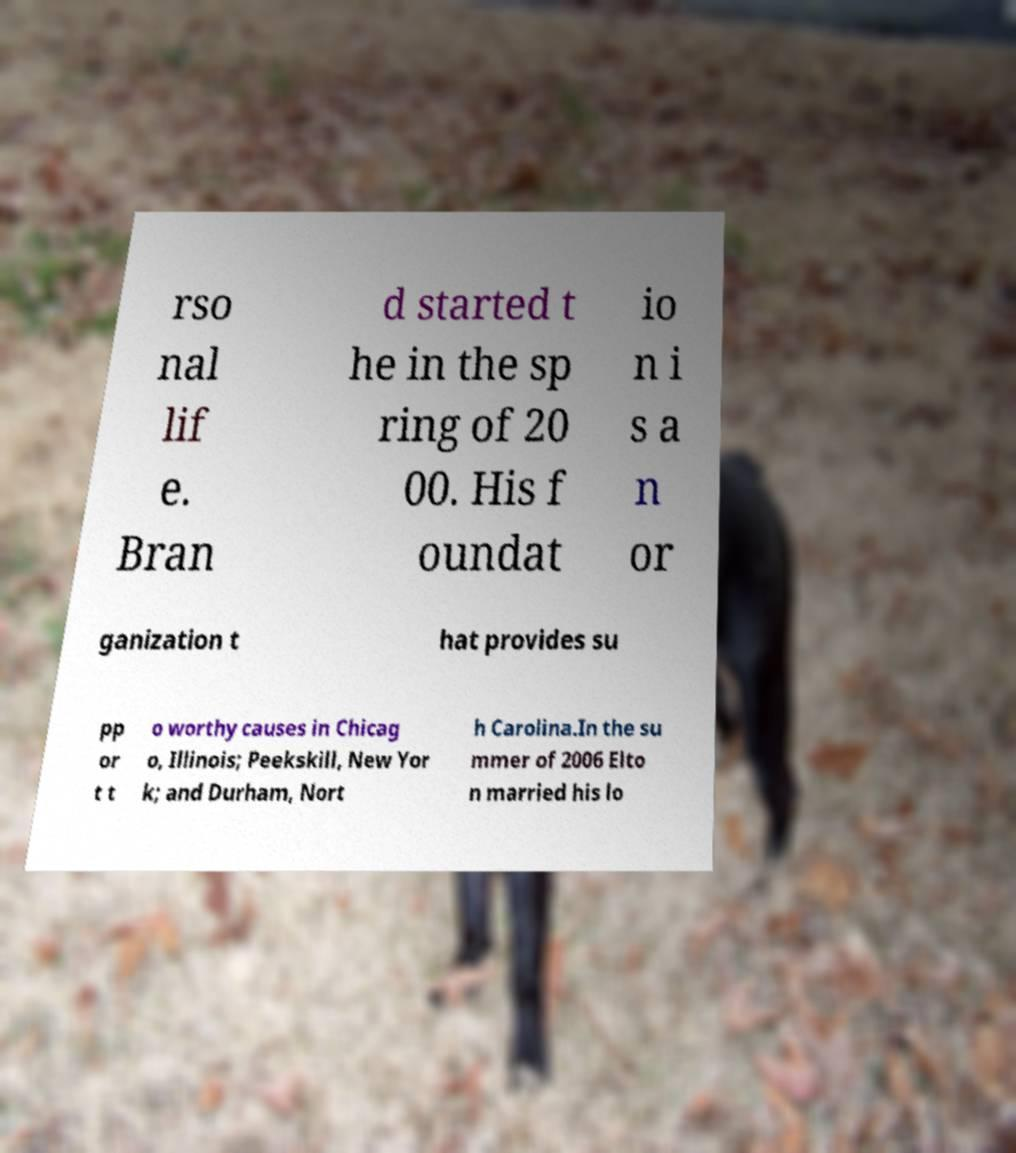What messages or text are displayed in this image? I need them in a readable, typed format. rso nal lif e. Bran d started t he in the sp ring of 20 00. His f oundat io n i s a n or ganization t hat provides su pp or t t o worthy causes in Chicag o, Illinois; Peekskill, New Yor k; and Durham, Nort h Carolina.In the su mmer of 2006 Elto n married his lo 